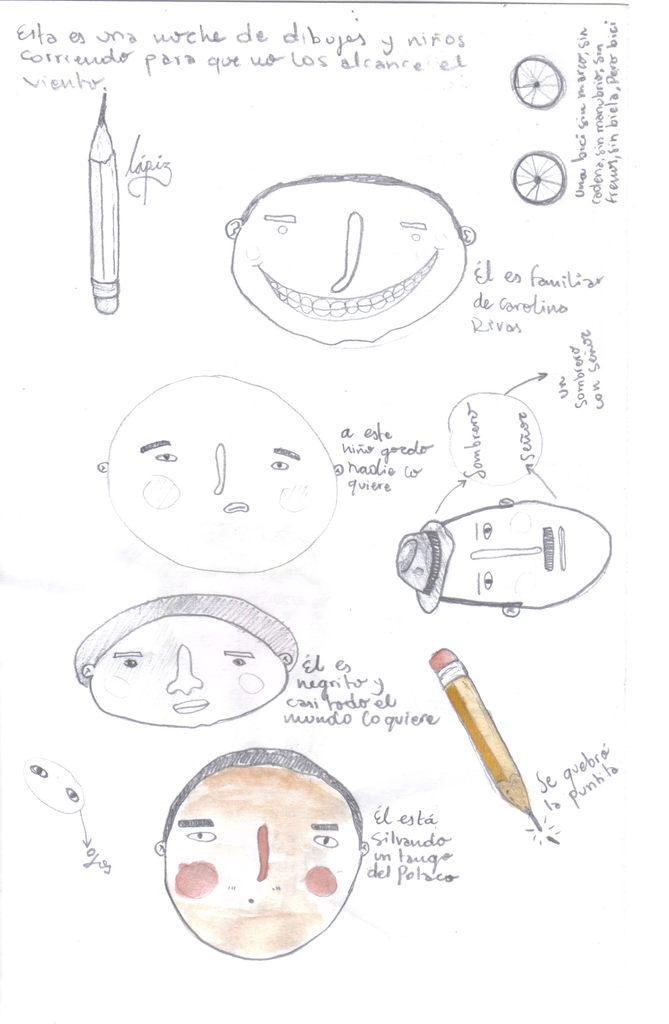What is depicted on the paper in the image? There are drawings on the paper in the image. Where is the nearest market to the location depicted in the drawings? The provided information does not include any location details, so it is impossible to determine the nearest market to the location depicted in the drawings. 